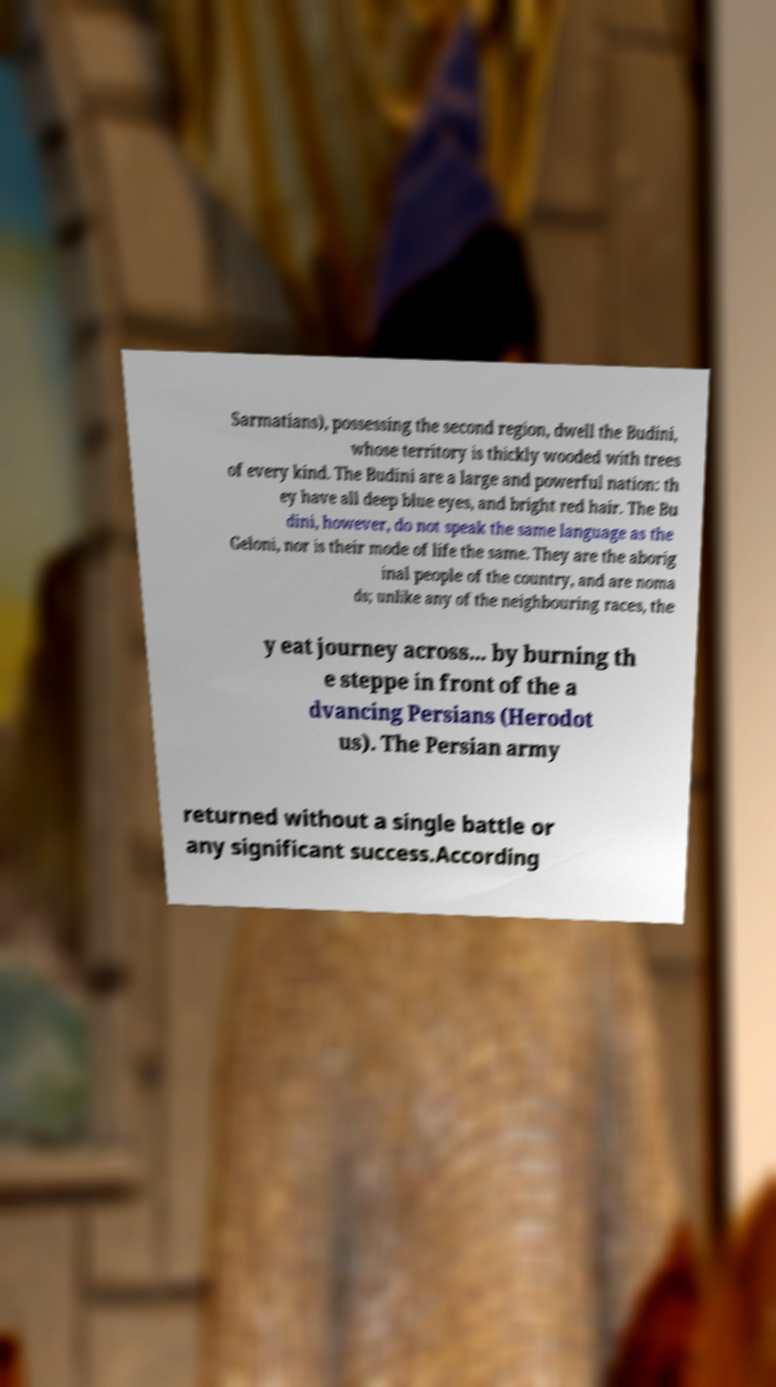For documentation purposes, I need the text within this image transcribed. Could you provide that? Sarmatians), possessing the second region, dwell the Budini, whose territory is thickly wooded with trees of every kind. The Budini are a large and powerful nation: th ey have all deep blue eyes, and bright red hair. The Bu dini, however, do not speak the same language as the Geloni, nor is their mode of life the same. They are the aborig inal people of the country, and are noma ds; unlike any of the neighbouring races, the y eat journey across... by burning th e steppe in front of the a dvancing Persians (Herodot us). The Persian army returned without a single battle or any significant success.According 